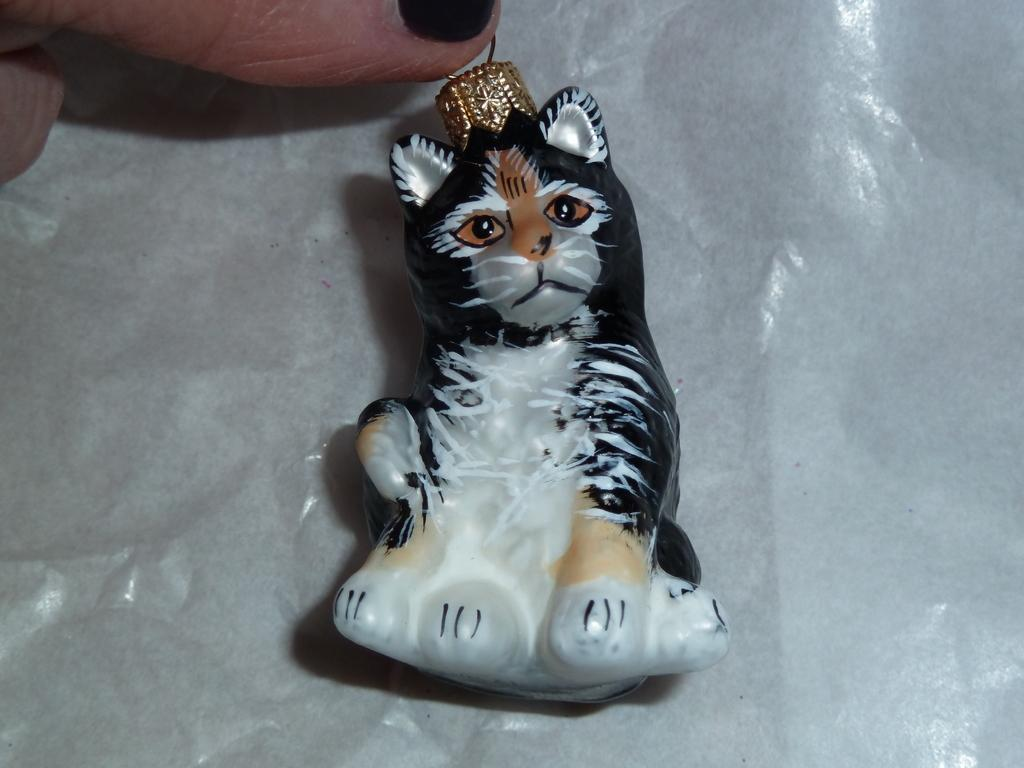What is the main subject in the center of the image? There is a toy in the center of the image. Can you describe any other elements in the image? A person's finger is present at the top left corner of the image. How many rabbits are hopping around the toy in the image? There are no rabbits present in the image. What type of celery is being used to power the toy in the image? There is no celery or any power source visible in the image; it is a toy without any visible means of operation. 